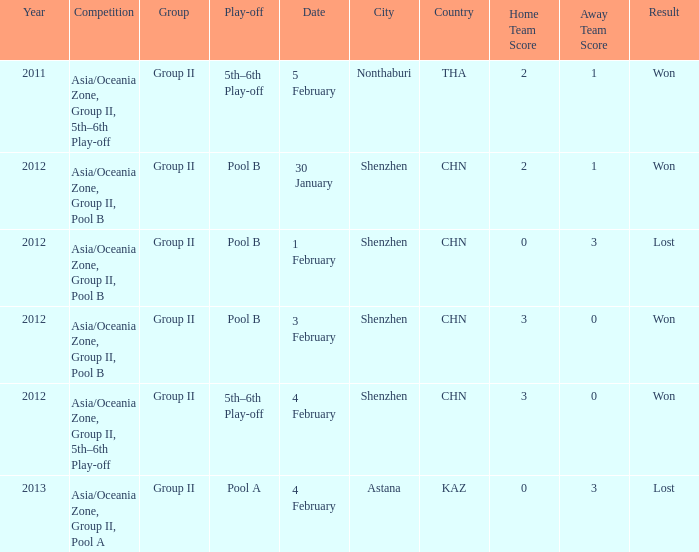What was the location for a year later than 2012? Astana ( KAZ ). 